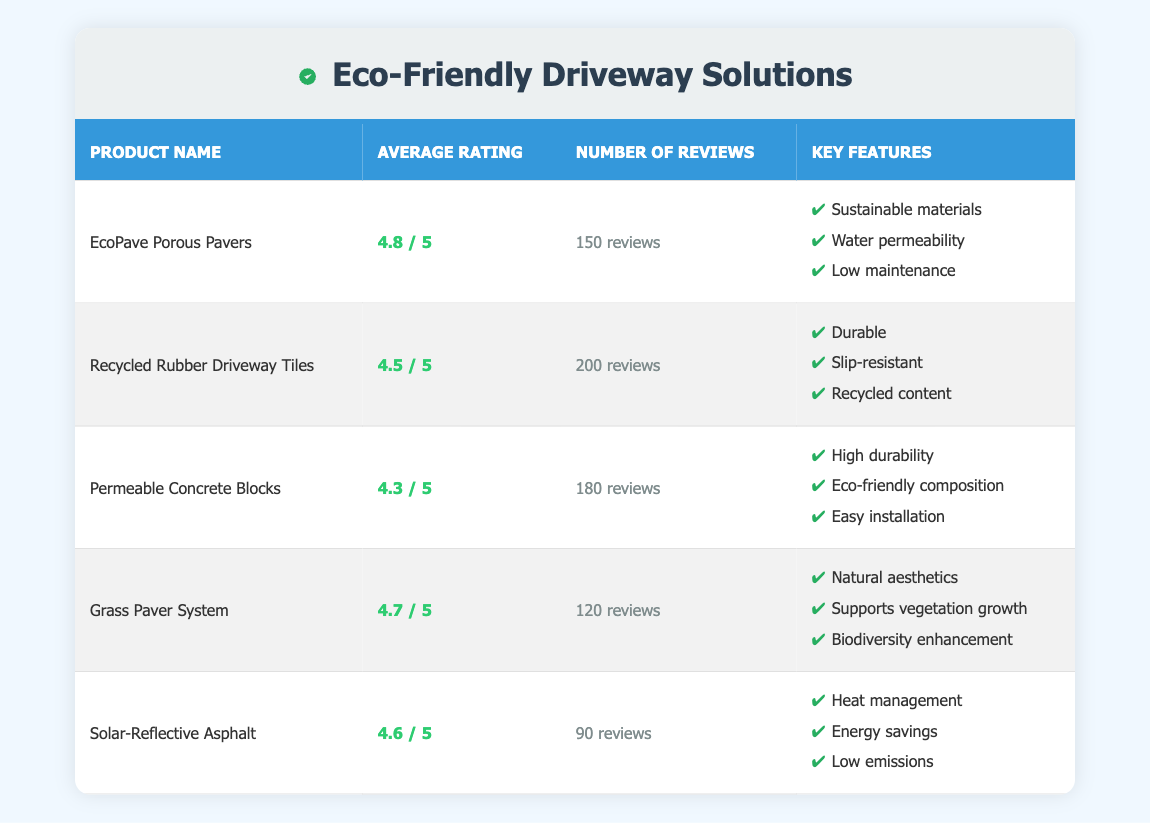What is the average rating of the EcoPave Porous Pavers? The table shows that the average rating of the EcoPave Porous Pavers is listed as 4.8.
Answer: 4.8 How many reviews did the Recycled Rubber Driveway Tiles receive? According to the table, the number of reviews for the Recycled Rubber Driveway Tiles is 200.
Answer: 200 Which product has the highest average rating? The highest average rating in the table is for EcoPave Porous Pavers at 4.8.
Answer: EcoPave Porous Pavers What is the average rating of all the products listed? The average ratings are 4.8, 4.5, 4.3, 4.7, and 4.6. Adding them gives 4.8 + 4.5 + 4.3 + 4.7 + 4.6 = 22.9, and dividing by 5 (the number of products) gives an average of 22.9 / 5 = 4.58.
Answer: 4.58 Are there more than 100 reviews for the Solar-Reflective Asphalt? The table states that the Solar-Reflective Asphalt has 90 reviews, which is less than 100. Thus, the answer is no.
Answer: No Which product features sustainable materials and has a rating above 4.5? The EcoPave Porous Pavers meet this criterion with a rating of 4.8 and lists sustainable materials as a feature. The Grass Paver System also meets this with a rating of 4.7 but does not specifically mention sustainable materials.
Answer: EcoPave Porous Pavers What is the difference in average ratings between the Grass Paver System and the Permeable Concrete Blocks? The average rating for the Grass Paver System is 4.7 and for the Permeable Concrete Blocks is 4.3. The difference is calculated as 4.7 - 4.3 = 0.4.
Answer: 0.4 Is the average rating of the Recycled Rubber Driveway Tiles above 4.0? The average rating of the Recycled Rubber Driveway Tiles is 4.5, which is indeed above 4.0. So, the answer is yes.
Answer: Yes How many total reviews were given for products with a rating of 4.5 or higher? The products with ratings of 4.5 or higher are EcoPave Porous Pavers (150 reviews), Recycled Rubber Driveway Tiles (200 reviews), Grass Paver System (120 reviews), and Solar-Reflective Asphalt (90 reviews). Adding their reviews gives 150 + 200 + 120 + 90 = 560.
Answer: 560 